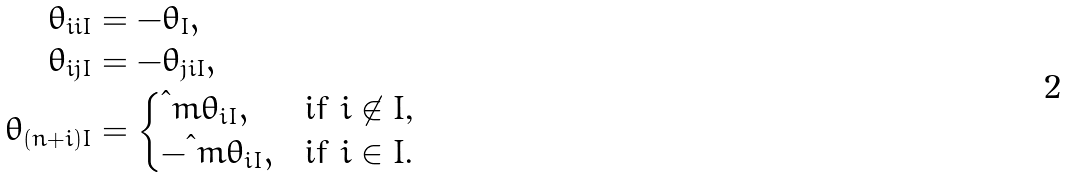Convert formula to latex. <formula><loc_0><loc_0><loc_500><loc_500>\theta _ { i i I } & = - \theta _ { I } , \\ \theta _ { i j I } & = - \theta _ { j i I } , \\ \theta _ { ( n + i ) I } & = \begin{cases} \i m \theta _ { i I } , & \text {if $i\not\in I$,} \\ - \i m \theta _ { i I } , & \text {if $i\in I$.} \end{cases}</formula> 